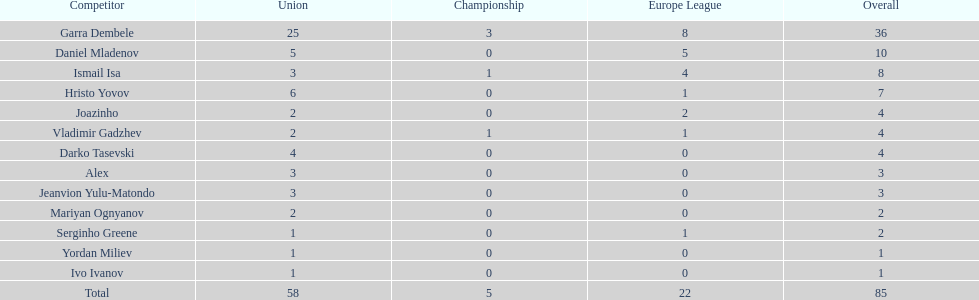What is the sum of the cup total and the europa league total? 27. 